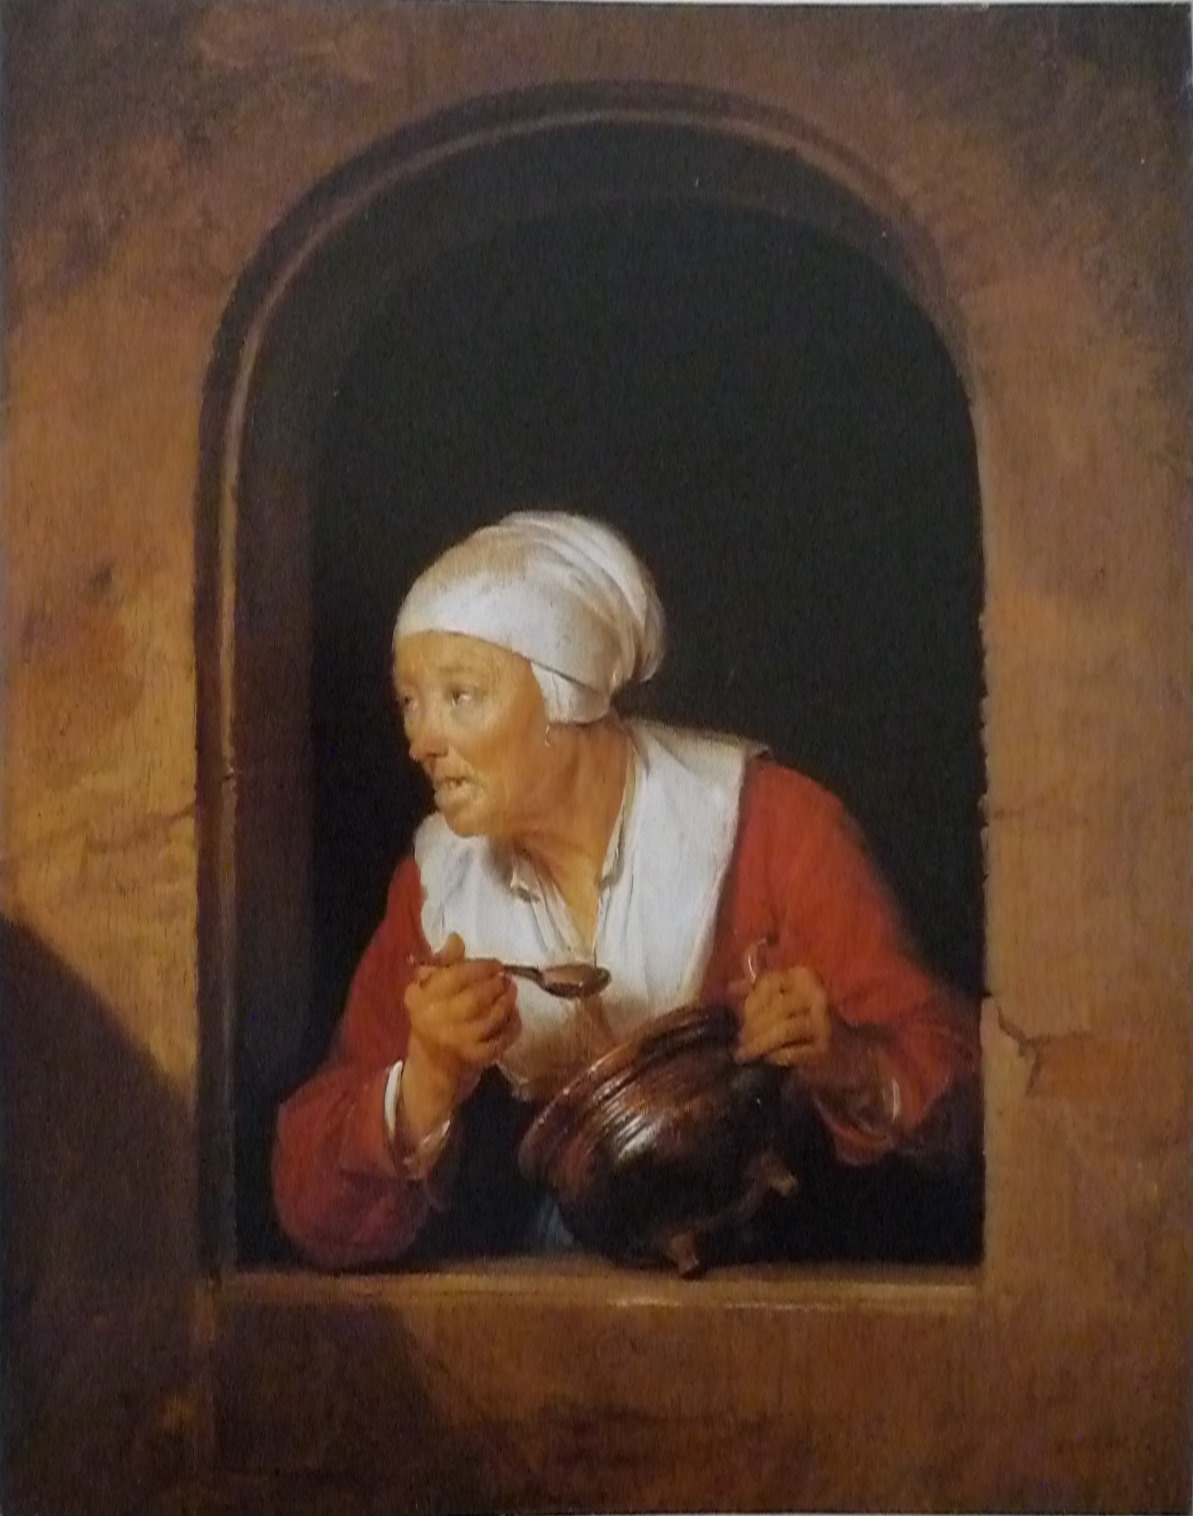Describe the woman's facial expression and what it might indicate about her mood or actions. The woman in the image has a look of surprise or alertness on her face. Her eyes are widened, and her mouth slightly open, as if she has just noticed something unexpected or heard an unusual sound. This expression suggests that she may be reacting to an unforeseen event, perhaps an intruder or a sudden noise outside her home. The attention to detail in her expression creates a narrative intrigue, drawing the viewer into her moment of surprise. 